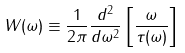<formula> <loc_0><loc_0><loc_500><loc_500>W ( \omega ) \equiv \frac { 1 } { 2 \pi } \frac { d ^ { 2 } } { d \omega ^ { 2 } } \left [ \frac { \omega } { \tau ( \omega ) } \right ]</formula> 